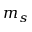Convert formula to latex. <formula><loc_0><loc_0><loc_500><loc_500>m _ { s }</formula> 